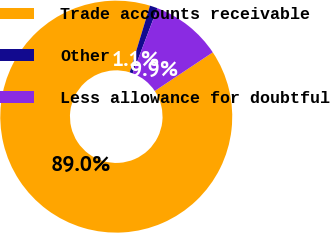<chart> <loc_0><loc_0><loc_500><loc_500><pie_chart><fcel>Trade accounts receivable<fcel>Other<fcel>Less allowance for doubtful<nl><fcel>89.05%<fcel>1.08%<fcel>9.87%<nl></chart> 